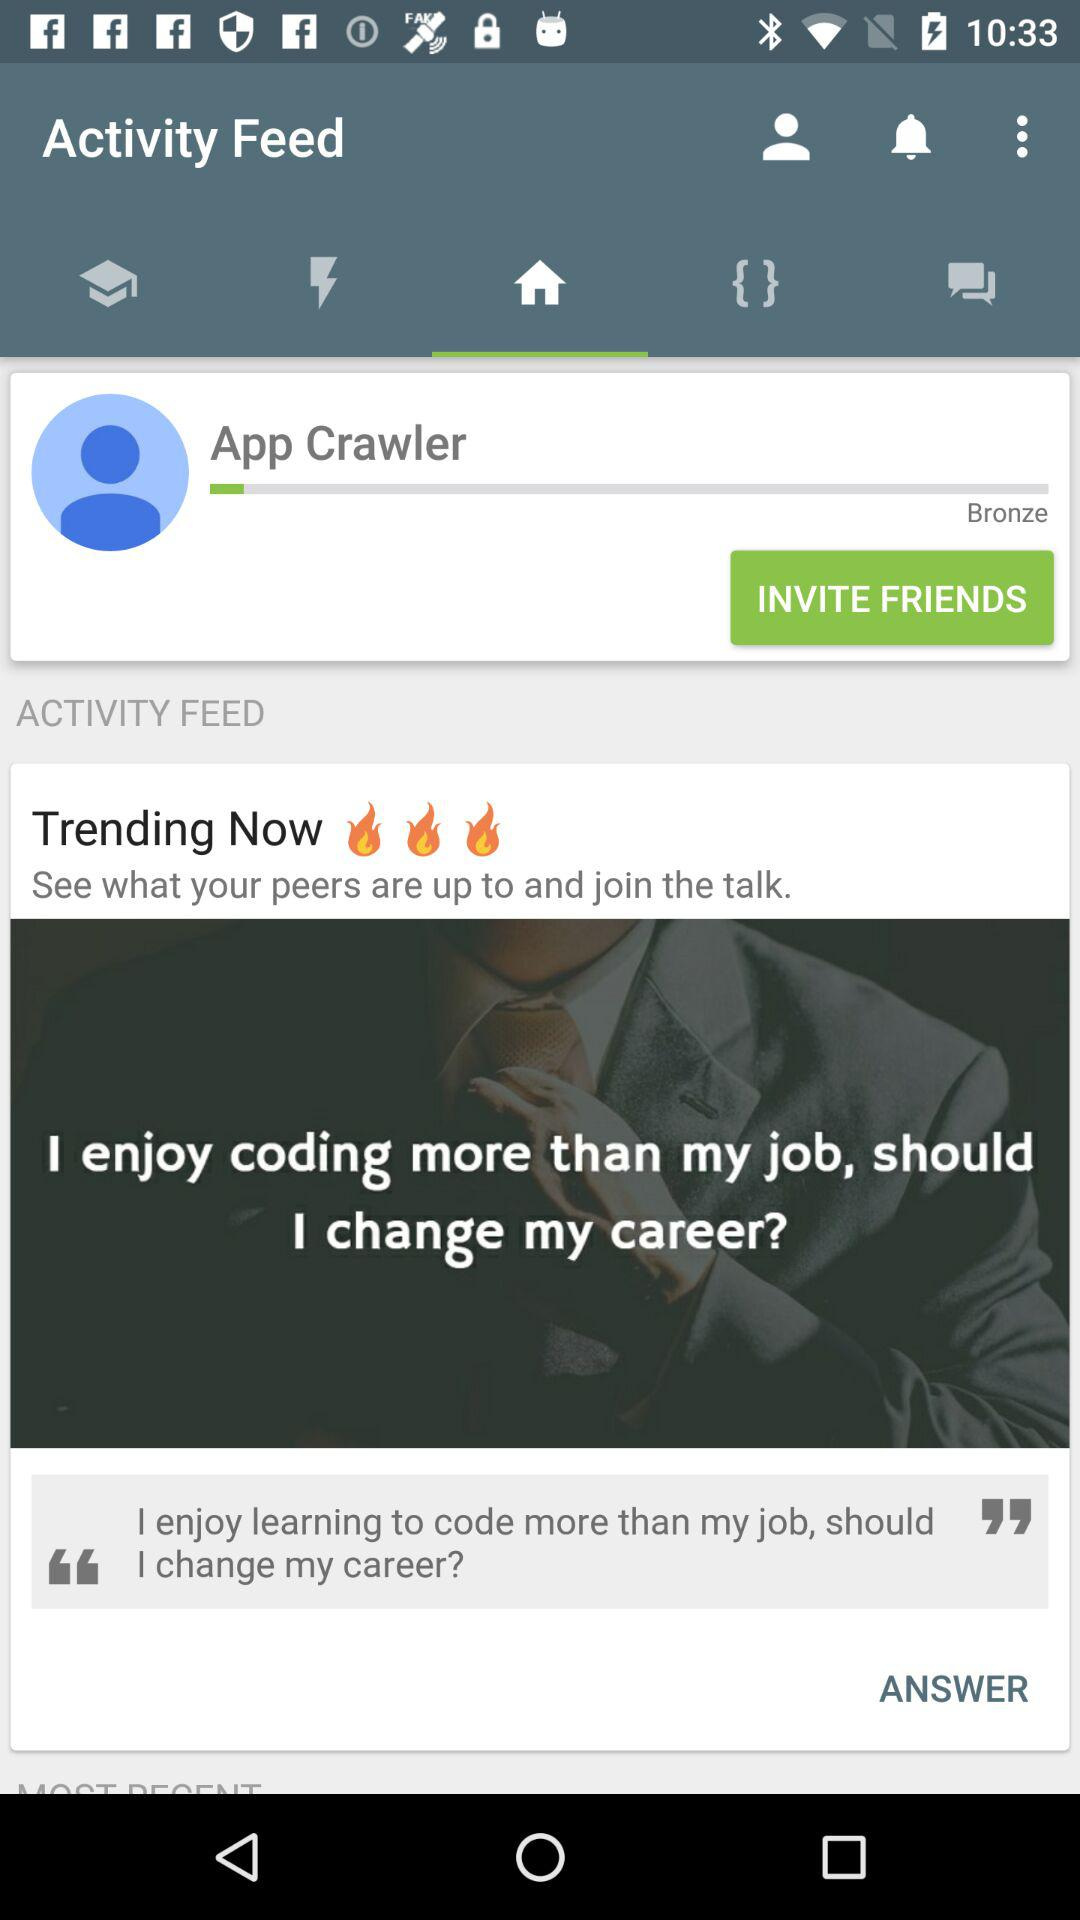How many fire emojis are there in the trending now section?
Answer the question using a single word or phrase. 3 